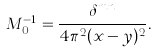<formula> <loc_0><loc_0><loc_500><loc_500>M _ { 0 } ^ { - 1 } = \frac { \delta ^ { m n } } { 4 \pi ^ { 2 } ( x - y ) ^ { 2 } } .</formula> 